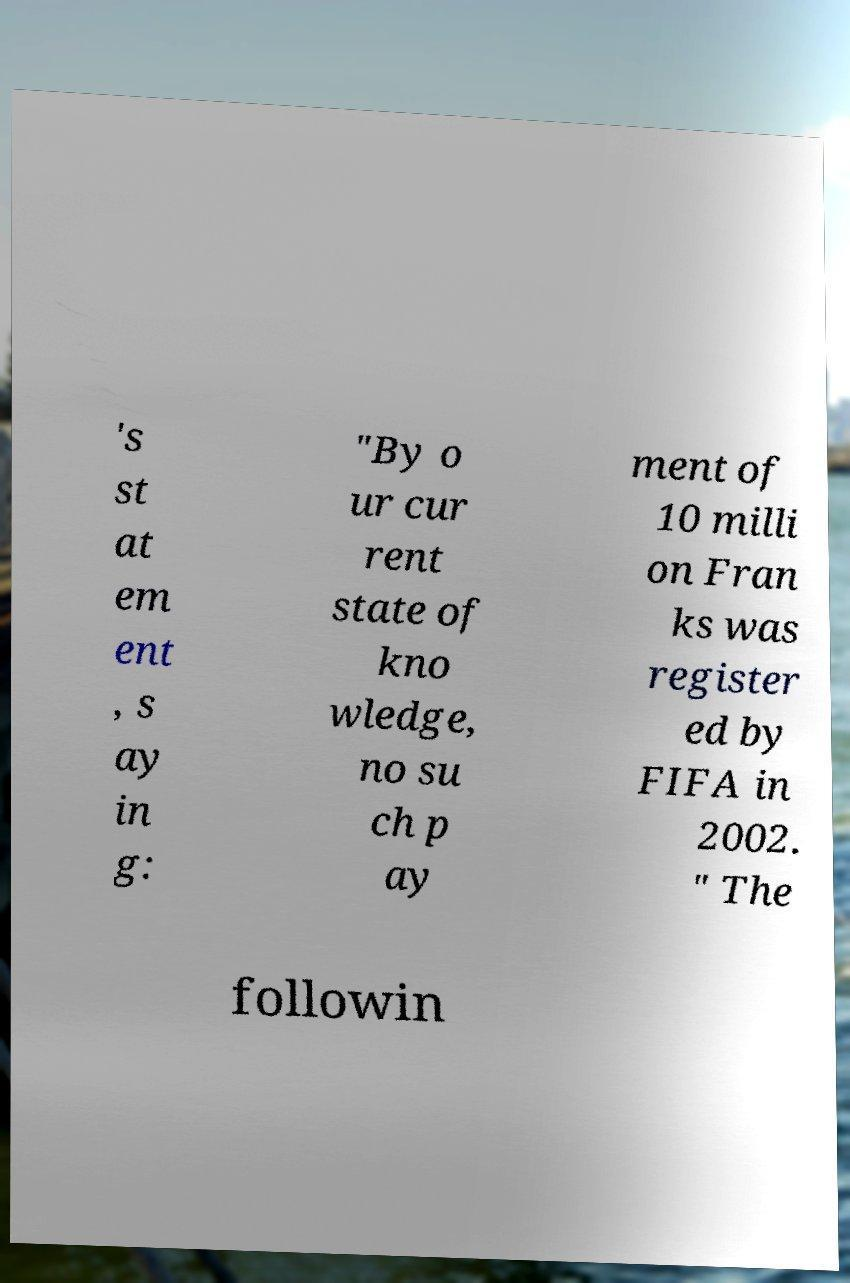Could you assist in decoding the text presented in this image and type it out clearly? 's st at em ent , s ay in g: "By o ur cur rent state of kno wledge, no su ch p ay ment of 10 milli on Fran ks was register ed by FIFA in 2002. " The followin 